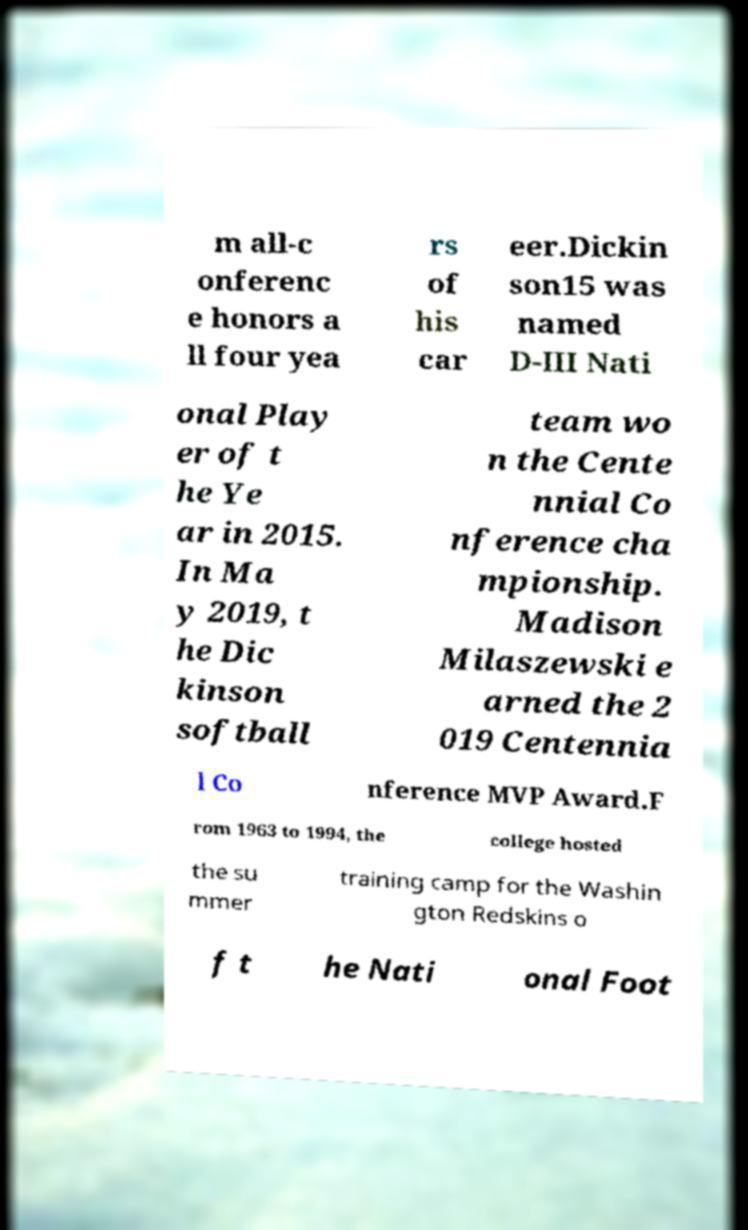I need the written content from this picture converted into text. Can you do that? m all-c onferenc e honors a ll four yea rs of his car eer.Dickin son15 was named D-III Nati onal Play er of t he Ye ar in 2015. In Ma y 2019, t he Dic kinson softball team wo n the Cente nnial Co nference cha mpionship. Madison Milaszewski e arned the 2 019 Centennia l Co nference MVP Award.F rom 1963 to 1994, the college hosted the su mmer training camp for the Washin gton Redskins o f t he Nati onal Foot 